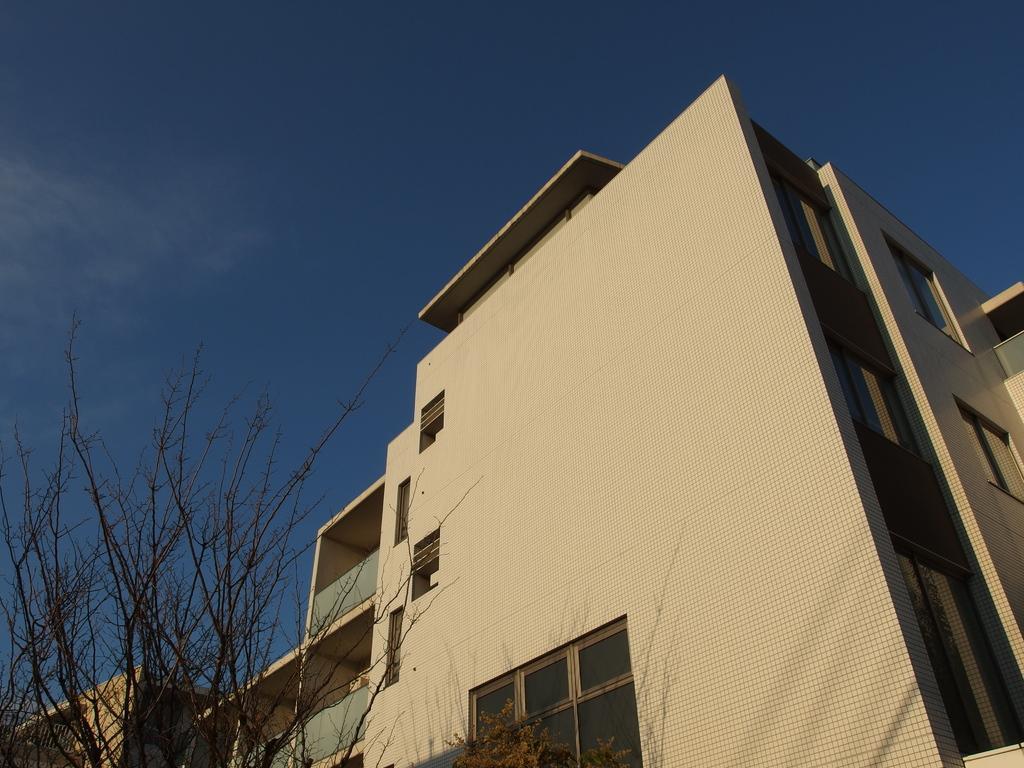Describe this image in one or two sentences. In this image at the bottom there are some buildings and trees, at the top of the image there is sky. 